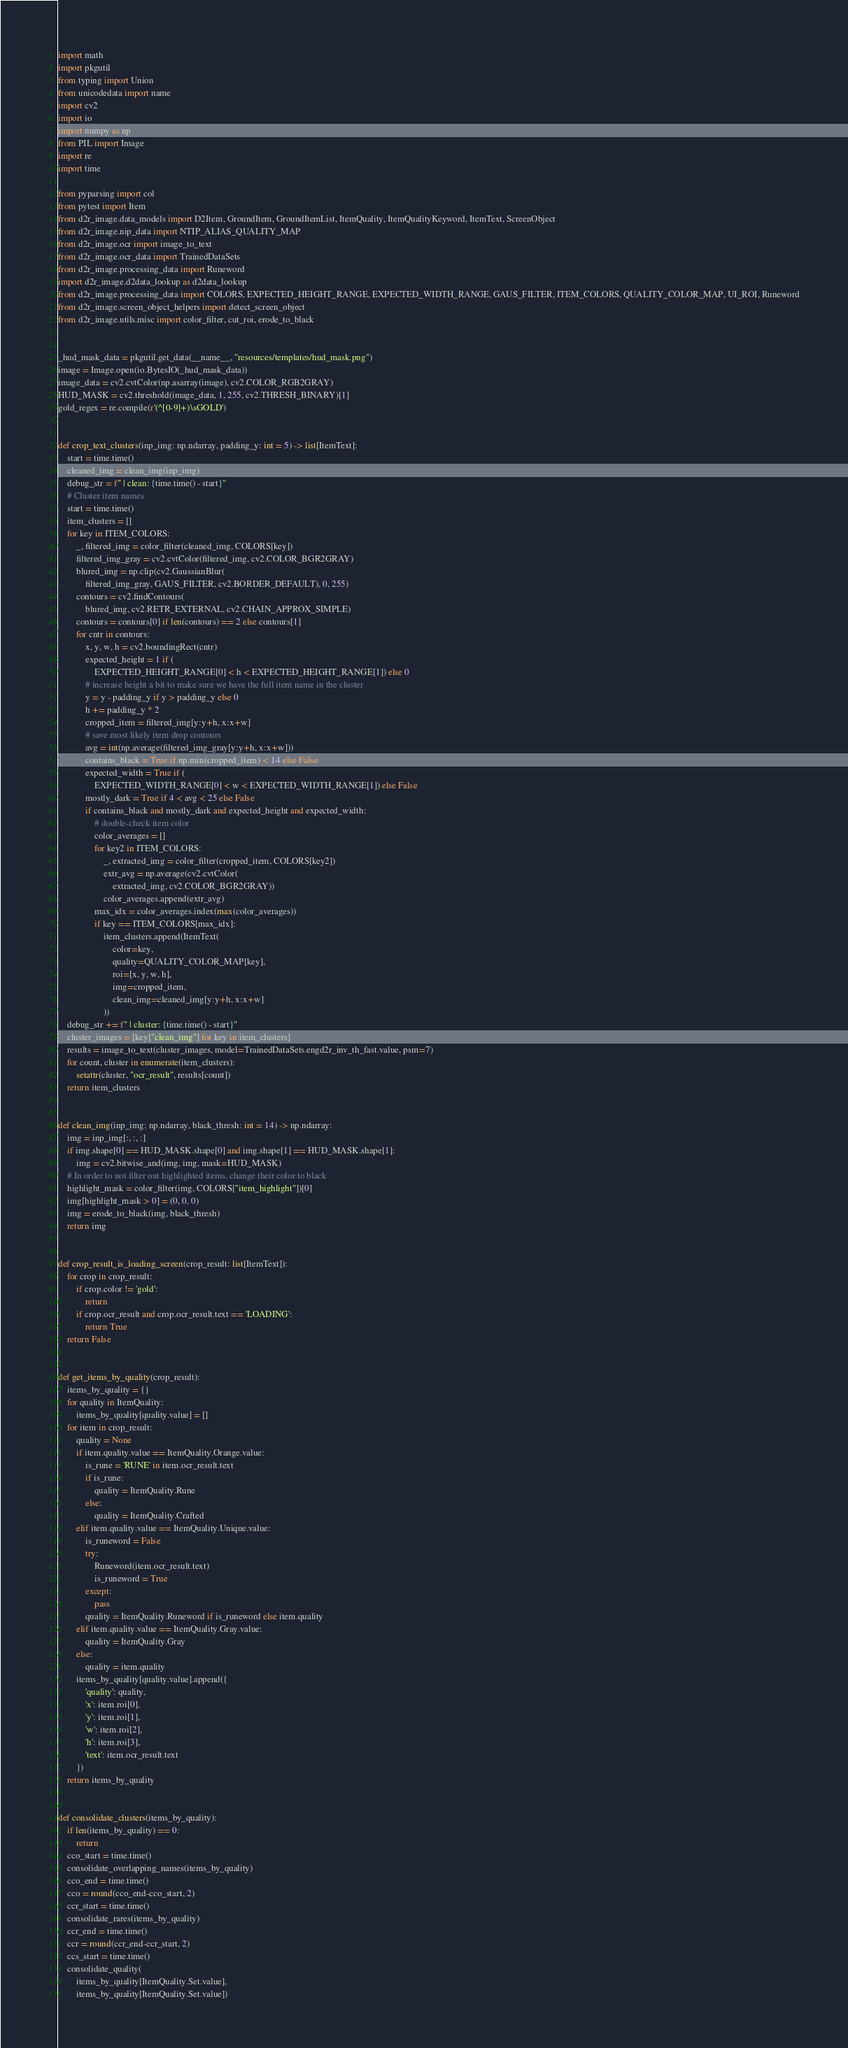Convert code to text. <code><loc_0><loc_0><loc_500><loc_500><_Python_>import math
import pkgutil
from typing import Union
from unicodedata import name
import cv2
import io
import numpy as np
from PIL import Image
import re
import time

from pyparsing import col
from pytest import Item
from d2r_image.data_models import D2Item, GroundItem, GroundItemList, ItemQuality, ItemQualityKeyword, ItemText, ScreenObject
from d2r_image.nip_data import NTIP_ALIAS_QUALITY_MAP
from d2r_image.ocr import image_to_text
from d2r_image.ocr_data import TrainedDataSets
from d2r_image.processing_data import Runeword
import d2r_image.d2data_lookup as d2data_lookup
from d2r_image.processing_data import COLORS, EXPECTED_HEIGHT_RANGE, EXPECTED_WIDTH_RANGE, GAUS_FILTER, ITEM_COLORS, QUALITY_COLOR_MAP, UI_ROI, Runeword
from d2r_image.screen_object_helpers import detect_screen_object
from d2r_image.utils.misc import color_filter, cut_roi, erode_to_black


_hud_mask_data = pkgutil.get_data(__name__, "resources/templates/hud_mask.png")
image = Image.open(io.BytesIO(_hud_mask_data))
image_data = cv2.cvtColor(np.asarray(image), cv2.COLOR_RGB2GRAY)
HUD_MASK = cv2.threshold(image_data, 1, 255, cv2.THRESH_BINARY)[1]
gold_regex = re.compile(r'(^[0-9]+)\sGOLD')


def crop_text_clusters(inp_img: np.ndarray, padding_y: int = 5) -> list[ItemText]:
    start = time.time()
    cleaned_img = clean_img(inp_img)
    debug_str = f" | clean: {time.time() - start}"
    # Cluster item names
    start = time.time()
    item_clusters = []
    for key in ITEM_COLORS:
        _, filtered_img = color_filter(cleaned_img, COLORS[key])
        filtered_img_gray = cv2.cvtColor(filtered_img, cv2.COLOR_BGR2GRAY)
        blured_img = np.clip(cv2.GaussianBlur(
            filtered_img_gray, GAUS_FILTER, cv2.BORDER_DEFAULT), 0, 255)
        contours = cv2.findContours(
            blured_img, cv2.RETR_EXTERNAL, cv2.CHAIN_APPROX_SIMPLE)
        contours = contours[0] if len(contours) == 2 else contours[1]
        for cntr in contours:
            x, y, w, h = cv2.boundingRect(cntr)
            expected_height = 1 if (
                EXPECTED_HEIGHT_RANGE[0] < h < EXPECTED_HEIGHT_RANGE[1]) else 0
            # increase height a bit to make sure we have the full item name in the cluster
            y = y - padding_y if y > padding_y else 0
            h += padding_y * 2
            cropped_item = filtered_img[y:y+h, x:x+w]
            # save most likely item drop contours
            avg = int(np.average(filtered_img_gray[y:y+h, x:x+w]))
            contains_black = True if np.min(cropped_item) < 14 else False
            expected_width = True if (
                EXPECTED_WIDTH_RANGE[0] < w < EXPECTED_WIDTH_RANGE[1]) else False
            mostly_dark = True if 4 < avg < 25 else False
            if contains_black and mostly_dark and expected_height and expected_width:
                # double-check item color
                color_averages = []
                for key2 in ITEM_COLORS:
                    _, extracted_img = color_filter(cropped_item, COLORS[key2])
                    extr_avg = np.average(cv2.cvtColor(
                        extracted_img, cv2.COLOR_BGR2GRAY))
                    color_averages.append(extr_avg)
                max_idx = color_averages.index(max(color_averages))
                if key == ITEM_COLORS[max_idx]:
                    item_clusters.append(ItemText(
                        color=key,
                        quality=QUALITY_COLOR_MAP[key],
                        roi=[x, y, w, h],
                        img=cropped_item,
                        clean_img=cleaned_img[y:y+h, x:x+w]
                    ))
    debug_str += f" | cluster: {time.time() - start}"
    cluster_images = [key["clean_img"] for key in item_clusters]
    results = image_to_text(cluster_images, model=TrainedDataSets.engd2r_inv_th_fast.value, psm=7)
    for count, cluster in enumerate(item_clusters):
        setattr(cluster, "ocr_result", results[count])
    return item_clusters


def clean_img(inp_img: np.ndarray, black_thresh: int = 14) -> np.ndarray:
    img = inp_img[:, :, :]
    if img.shape[0] == HUD_MASK.shape[0] and img.shape[1] == HUD_MASK.shape[1]:
        img = cv2.bitwise_and(img, img, mask=HUD_MASK)
    # In order to not filter out highlighted items, change their color to black
    highlight_mask = color_filter(img, COLORS["item_highlight"])[0]
    img[highlight_mask > 0] = (0, 0, 0)
    img = erode_to_black(img, black_thresh)
    return img


def crop_result_is_loading_screen(crop_result: list[ItemText]):
    for crop in crop_result:
        if crop.color != 'gold':
            return
        if crop.ocr_result and crop.ocr_result.text == 'LOADING':
            return True
    return False


def get_items_by_quality(crop_result):
    items_by_quality = {}
    for quality in ItemQuality:
        items_by_quality[quality.value] = []
    for item in crop_result:
        quality = None
        if item.quality.value == ItemQuality.Orange.value:
            is_rune = 'RUNE' in item.ocr_result.text
            if is_rune:
                quality = ItemQuality.Rune
            else:
                quality = ItemQuality.Crafted
        elif item.quality.value == ItemQuality.Unique.value:
            is_runeword = False
            try:
                Runeword(item.ocr_result.text)
                is_runeword = True
            except:
                pass
            quality = ItemQuality.Runeword if is_runeword else item.quality
        elif item.quality.value == ItemQuality.Gray.value:
            quality = ItemQuality.Gray
        else:
            quality = item.quality
        items_by_quality[quality.value].append({
            'quality': quality,
            'x': item.roi[0],
            'y': item.roi[1],
            'w': item.roi[2],
            'h': item.roi[3],
            'text': item.ocr_result.text
        })
    return items_by_quality


def consolidate_clusters(items_by_quality):
    if len(items_by_quality) == 0:
        return
    cco_start = time.time()
    consolidate_overlapping_names(items_by_quality)
    cco_end = time.time()
    cco = round(cco_end-cco_start, 2)
    ccr_start = time.time()
    consolidate_rares(items_by_quality)
    ccr_end = time.time()
    ccr = round(ccr_end-ccr_start, 2)
    ccs_start = time.time()
    consolidate_quality(
        items_by_quality[ItemQuality.Set.value],
        items_by_quality[ItemQuality.Set.value])</code> 